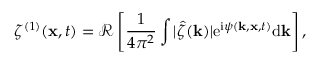<formula> <loc_0><loc_0><loc_500><loc_500>\zeta ^ { ( 1 ) } ( x , t ) = \mathcal { R } \left [ \frac { 1 } { 4 \pi ^ { 2 } } \int | \hat { \zeta } ( k ) | e ^ { i \psi ( k , x , t ) } d k \right ] ,</formula> 